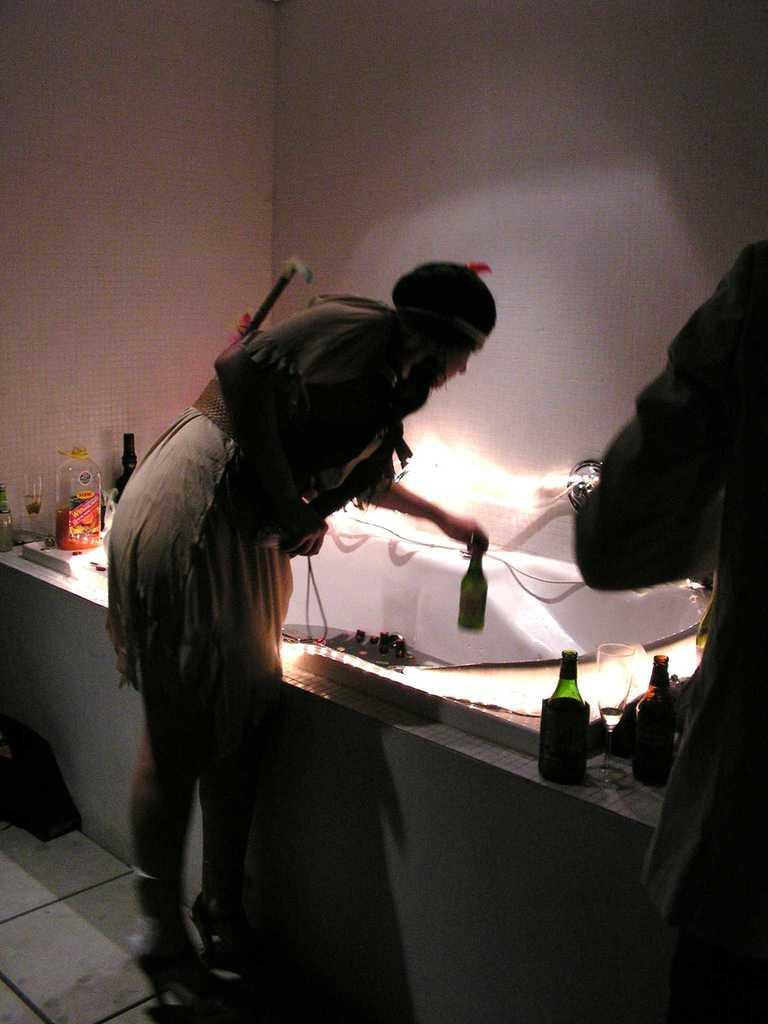What is the main subject of the image? There is a person in the image. Where is the person located in relation to other objects? The person is standing near a table. What is the person doing in the image? The person is catching a bottle with his hands. What type of blade is being used to smash the bottle in the image? There is no blade or smashing action present in the image; the person is simply catching a bottle with his hands. 